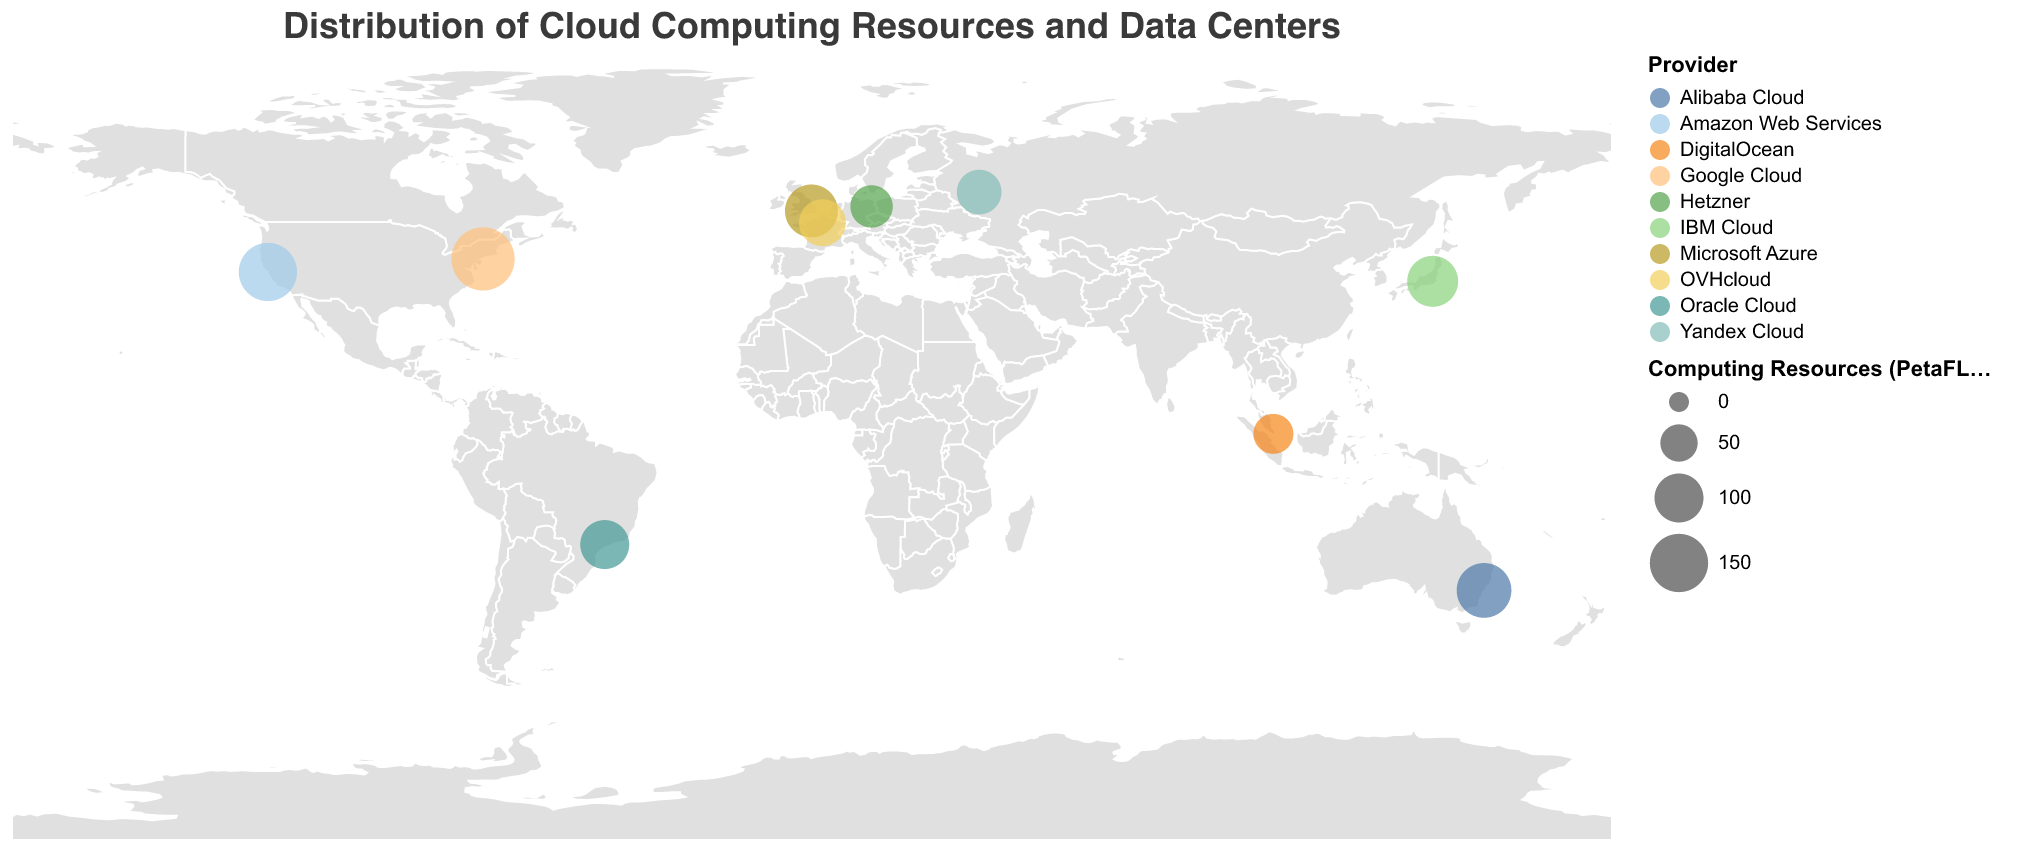What is the title of the figure? The title of the figure is positioned at the top and reads "Distribution of Cloud Computing Resources and Data Centers".
Answer: Distribution of Cloud Computing Resources and Data Centers How many total data centers are represented in the figure? Each circle on the map represents a data center, and counting all the circles gives us the total number of data centers.
Answer: 10 Which data center has the highest computing resources, and what is the value? By examining the sizes of the circles, the largest circle represents Google NYC under Google Cloud with 180 PetaFLOPS.
Answer: Google NYC, 180 PetaFLOPS Which data center is located furthest south? By looking at the latitude values, the data center with the smallest latitude value is Alibaba Sydney, which is furthest south at latitude -33.8688.
Answer: Alibaba Sydney What is the total computing power of all data centers located in the Americas? By summing the computing resources of AWS US West (N. California) (150 PetaFLOPS), Google NYC (180 PetaFLOPS), and Oracle São Paulo (100 PetaFLOPS): 150 + 180 + 100 = 430 PetaFLOPS.
Answer: 430 PetaFLOPS Which data centers belong to providers with privacy certifications related to GDPR, and where are they located? Google NYC has GDPR Compliant privacy certification and is located in New York City, USA.
Answer: Google NYC, New York City, USA Compare the computing resources of data centers with ISO certifications. Which one has the most? ISO certifications include AWS US West (N. California) (ISO 27001, 150 PetaFLOPS), Azure UK South (ISO 27018, 120 PetaFLOPS), Alibaba Sydney (ISO 27701, 130 PetaFLOPS), and Oracle São Paulo (ISO 27017, 100 PetaFLOPS). The highest is AWS US West (N. California) with 150 PetaFLOPS.
Answer: AWS US West (N. California) What is the average computing resource of all data centers? The total computing resources are the sum of all the centers: 150 + 180 + 120 + 90 + 110 + 70 + 130 + 60 + 80 + 100 = 1090. There are 10 data centers, so the average is 1090 / 10 = 109 PetaFLOPS.
Answer: 109 PetaFLOPS How many data centers have a privacy certification related to health care compliance? Only one data center, OVH Paris, is marked with HIPAA Compliant, which is related to health care privacy.
Answer: 1 Identify the data center with the least computing resources and state its privacy certification. The smallest circle, representing the data center with the least resources, belongs to DigitalOcean SGP1 with 60 PetaFLOPS and has PCI DSS certification.
Answer: DigitalOcean SGP1, PCI DSS 